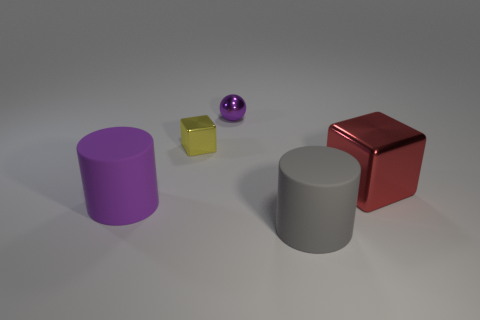What number of things are big things left of the tiny metallic ball or red shiny things?
Your answer should be very brief. 2. There is a large object that is on the left side of the shiny thing that is behind the yellow cube; what is it made of?
Your answer should be compact. Rubber. Are there an equal number of metallic cubes to the left of the big red object and big things to the left of the ball?
Give a very brief answer. Yes. How many things are either purple objects that are in front of the red block or things to the right of the purple matte object?
Offer a terse response. 5. There is a object that is both in front of the small yellow metallic thing and to the left of the gray rubber cylinder; what material is it?
Ensure brevity in your answer.  Rubber. What size is the shiny cube that is to the left of the object on the right side of the thing in front of the purple cylinder?
Your response must be concise. Small. Is the number of purple things greater than the number of small gray rubber cubes?
Provide a succinct answer. Yes. Are the large thing that is left of the tiny yellow object and the gray cylinder made of the same material?
Give a very brief answer. Yes. Is the number of big gray cylinders less than the number of small metal objects?
Your answer should be very brief. Yes. Are there any metal blocks in front of the small yellow object that is to the left of the large gray matte object to the right of the small yellow metal cube?
Offer a terse response. Yes. 